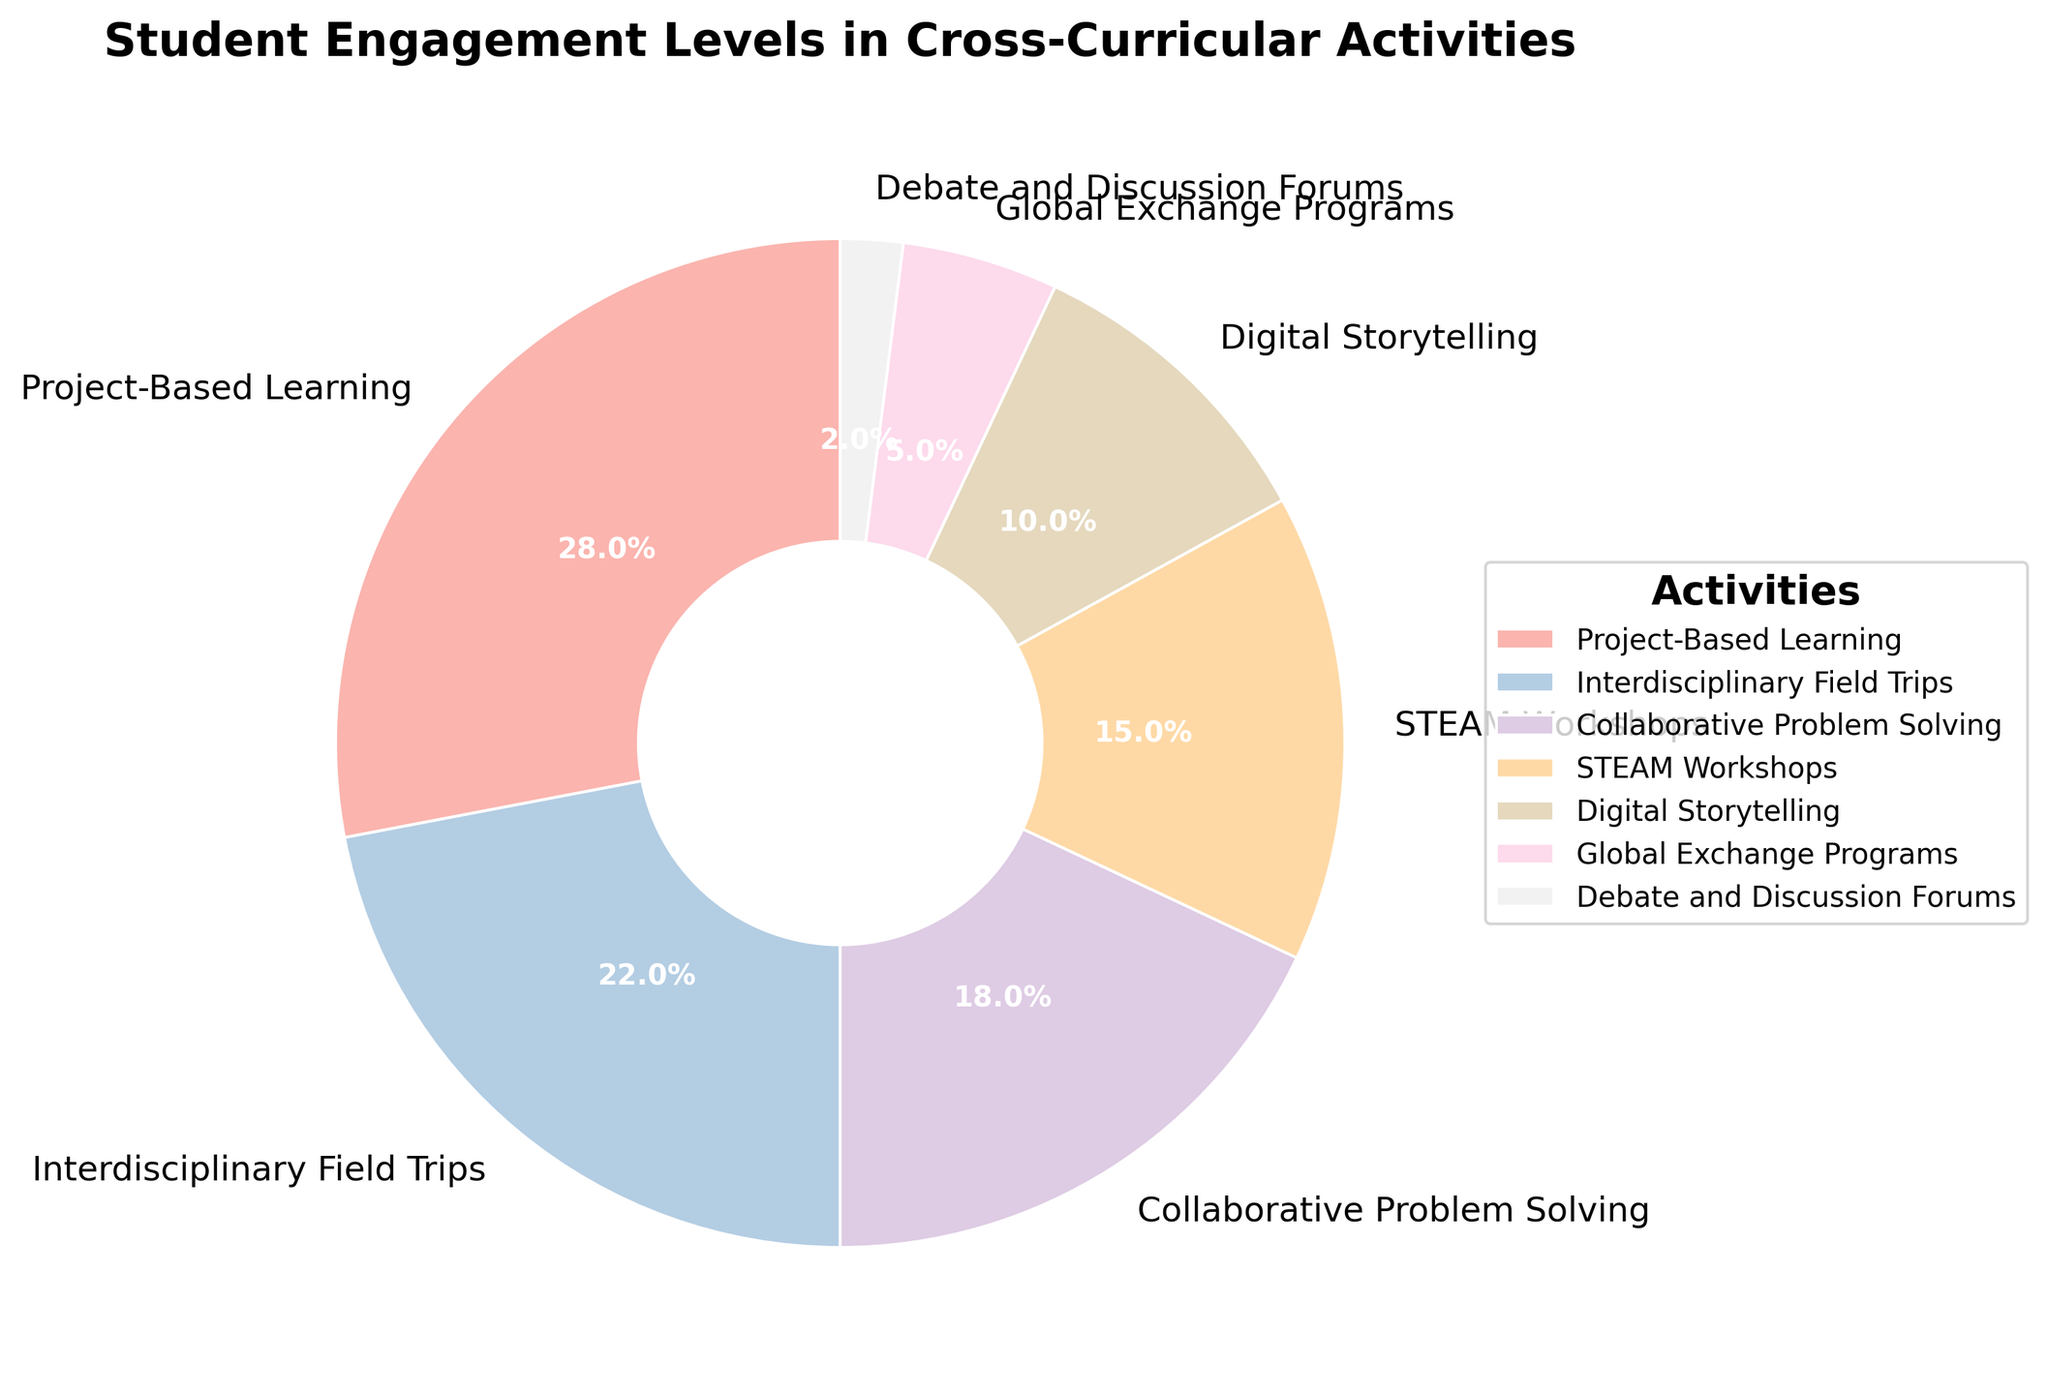What percentage of student engagement comes from Project-Based Learning and Interdisciplinary Field Trips combined? Add the percentages of Project-Based Learning (28%) and Interdisciplinary Field Trips (22%). 28% + 22% = 50%
Answer: 50% Which activity has the lowest student engagement percentage? Refer to the chart and identify the activity with the smallest segment. Debate and Discussion Forums have 2%, which is the smallest.
Answer: Debate and Discussion Forums Compare the student engagement levels of STEAM Workshops and Digital Storytelling. Which one is greater and by how much? STEAM Workshops have 15% and Digital Storytelling has 10%. Subtract 10% from 15% to find the difference. 15% - 10% = 5%
Answer: STEAM Workshops by 5% What's the average percentage of student engagement across all activities? Sum all the percentages: 28% + 22% + 18% + 15% + 10% + 5% + 2% = 100%. There are 7 activities. Average is 100% / 7 ≈ 14.3%
Answer: 14.3% Which activity segment has a larger visual size, Collaborative Problem Solving or Global Exchange Programs? Compare the sizes of the segments. Collaborative Problem Solving has 18% and Global Exchange Programs have 5%, so Collaborative Problem Solving is larger.
Answer: Collaborative Problem Solving How does the engagement percentage of Project-Based Learning compare to the sum of the percentages for Debate and Discussion Forums and Global Exchange Programs? Project-Based Learning is 28%. Sum Debate and Discussion Forums (2%) and Global Exchange Programs (5%) to get 7%. 28% is significantly greater than 7%.
Answer: Project-Based Learning is significantly greater Identify which two adjacent activities have the closest student engagement percentages. Look for pairs of segments with the smallest difference. STEAM Workshops (15%) and Digital Storytelling (10%) have a 5% difference, which is the smallest.
Answer: STEAM Workshops and Digital Storytelling If the percentage of Global Exchange Programs doubled, how would its engagement compare to that of STEAM Workshops? The current percentage for Global Exchange Programs is 5%. Doubling it gives 5% * 2 = 10%. This is still less than STEAM Workshops, which have 15%.
Answer: It would still be less What is the difference in engagement percentage between the most and least engaging activities? The highest is Project-Based Learning at 28% and the lowest is Debate and Discussion Forums at 2%. Subtract 2% from 28%. 28% - 2% = 26%
Answer: 26% What fraction of the total engagement is made up by Collaborative Problem Solving and STEAM Workshops combined? Add the percentages: 18% + 15% = 33%. Convert this to a fraction: 33/100 = 33%.
Answer: 33% 